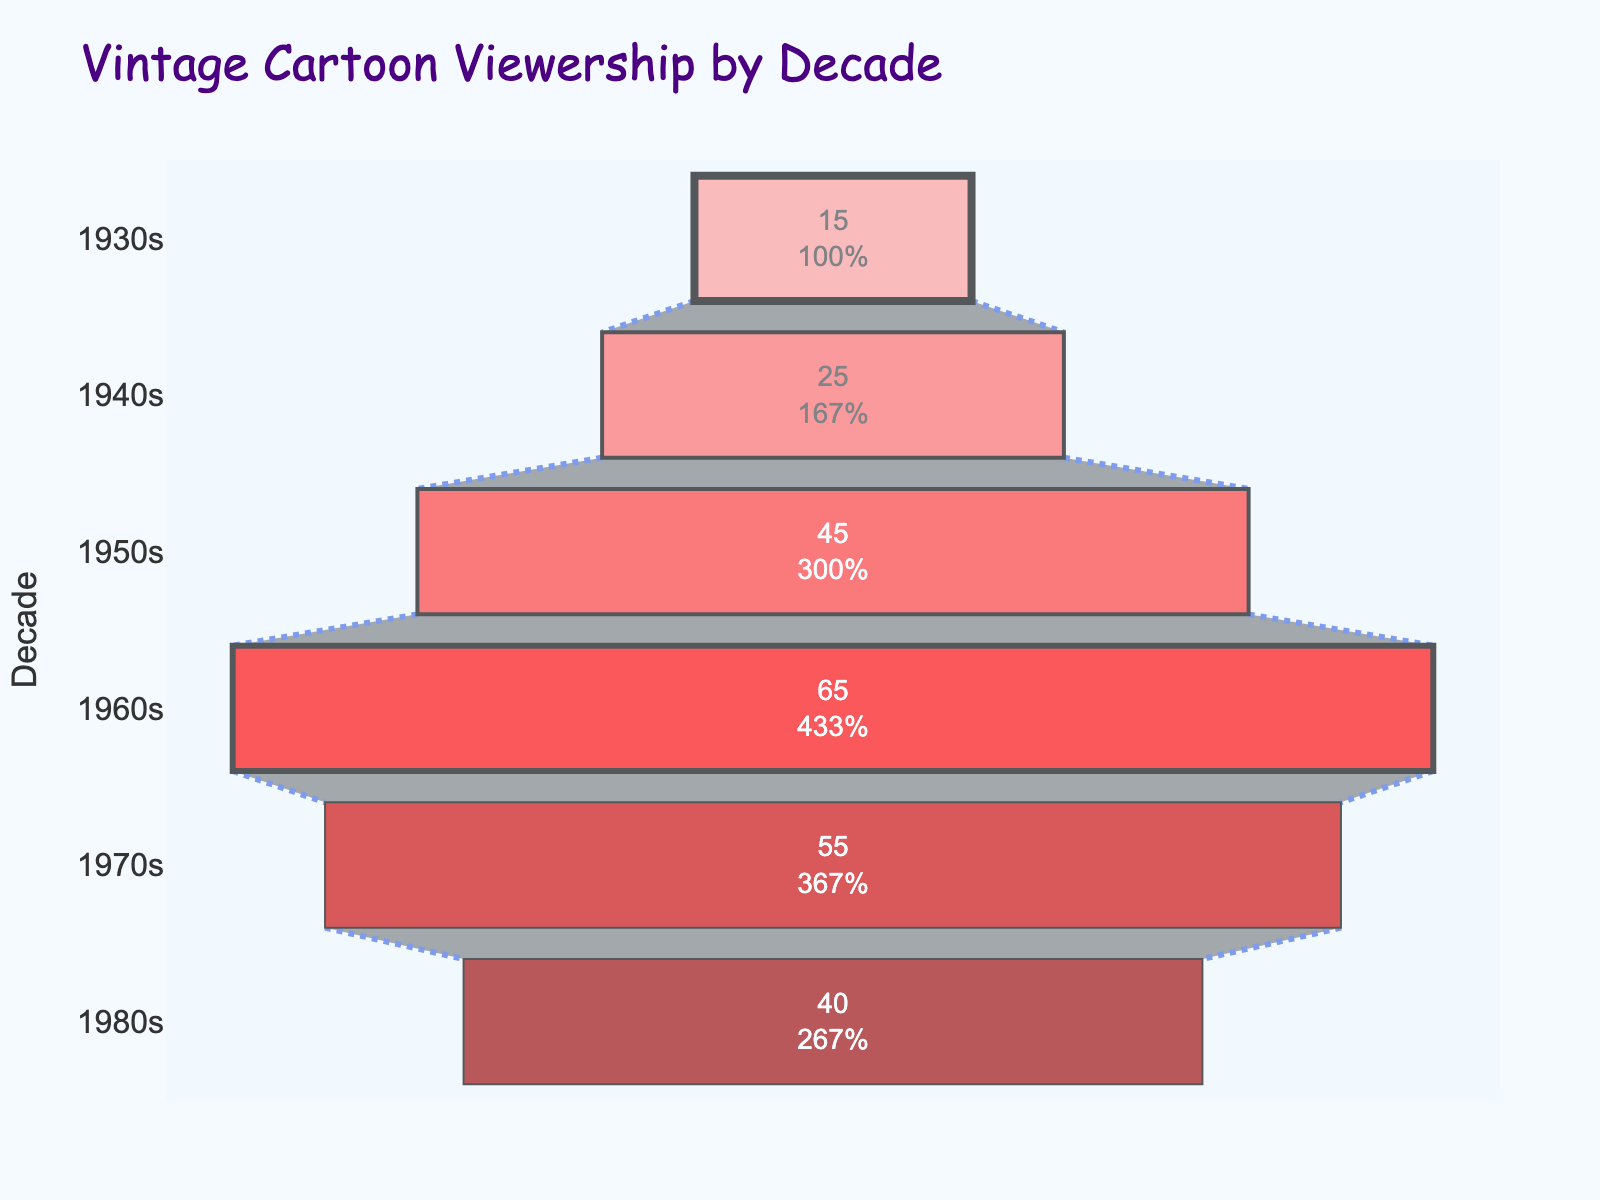What is the title of the figure? The title is located at the top of the figure. It is "Vintage Cartoon Viewership by Decade" and is displayed in a comic font to match the theme.
Answer: Vintage Cartoon Viewership by Decade How many decades are displayed in the figure? The decades are listed along the vertical axis (y-axis). They are 1930s, 1940s, 1950s, 1960s, 1970s, and 1980s. Counting them gives a total of 6 decades.
Answer: 6 Which decade had the highest viewership? The viewership values are displayed within each segment of the funnel. The 1960s segment is the widest, indicating it had the highest viewership of 65 million.
Answer: 1960s What is the viewership difference between the 1960s and the 1980s? The viewership in the 1960s was 65 million, and in the 1980s, it was 40 million. The difference is calculated as 65 - 40 = 25 million.
Answer: 25 million Which decade saw a decline in viewership compared to its previous decade? By comparing each decade's viewership to its previous one, we notice the following changes: 1930s to 1940s (increase), 1940s to 1950s (increase), 1950s to 1960s (increase), 1960s to 1970s (decrease), and 1970s to 1980s (decrease). Both the 1970s and 1980s experienced declines, but the first drop occurred from the 1960s to the 1970s.
Answer: 1970s What percentage of the initial viewership (1930s) was maintained in the 1980s? The initial viewership in the 1930s was 15 million. The viewership in the 1980s was 40 million. The percentage is calculated as (40 / 15) * 100%, which equals approximately 266.67%.
Answer: 266.67% What is the average viewership across all the decades? Adding up the viewership values: 15 + 25 + 45 + 65 + 55 + 40 = 245 million. Dividing by the number of decades (6) gives us an average viewership of approximately 245 / 6 = 40.83 million.
Answer: 40.83 million Which two consecutive decades had the smallest change in viewership? To determine this, calculate the absolute differences between consecutive decades: 
1940s - 1930s = 25 - 15 = 10 million,
1950s - 1940s = 45 - 25 = 20 million,
1960s - 1950s = 65 - 45 = 20 million,
1970s - 1960s = 65 - 55 = 10 million,
1980s - 1970s = 55 - 40 = 15 million.
The smallest change is 10 million, which occurs between the 1930s and 1940s and the 1960s and 1970s.
Answer: 1930s-1940s and 1960s-1970s What's the median viewership from the data provided? The values in ascending order are 15, 25, 40, 45, 55, 65. With an even number of values, the median is the average of the 3rd and 4th values: (40 + 45) / 2 = 42.5 million.
Answer: 42.5 million 